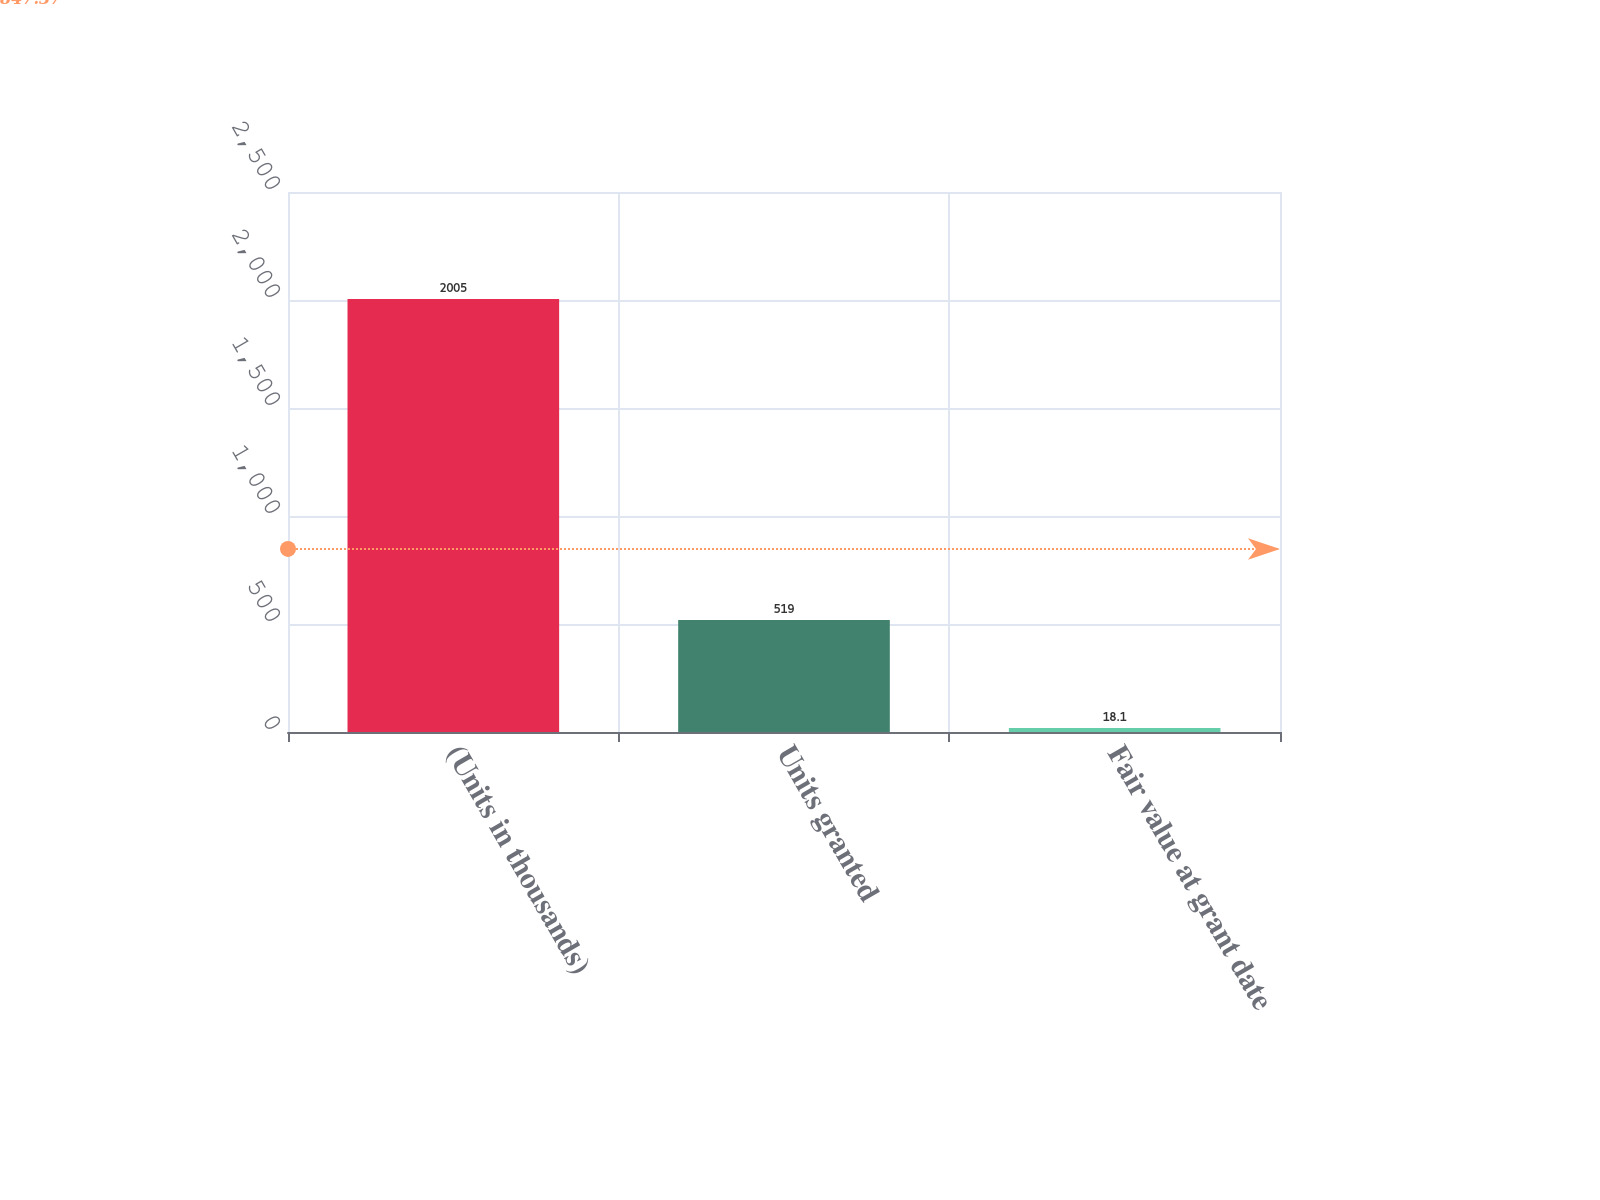Convert chart to OTSL. <chart><loc_0><loc_0><loc_500><loc_500><bar_chart><fcel>(Units in thousands)<fcel>Units granted<fcel>Fair value at grant date<nl><fcel>2005<fcel>519<fcel>18.1<nl></chart> 